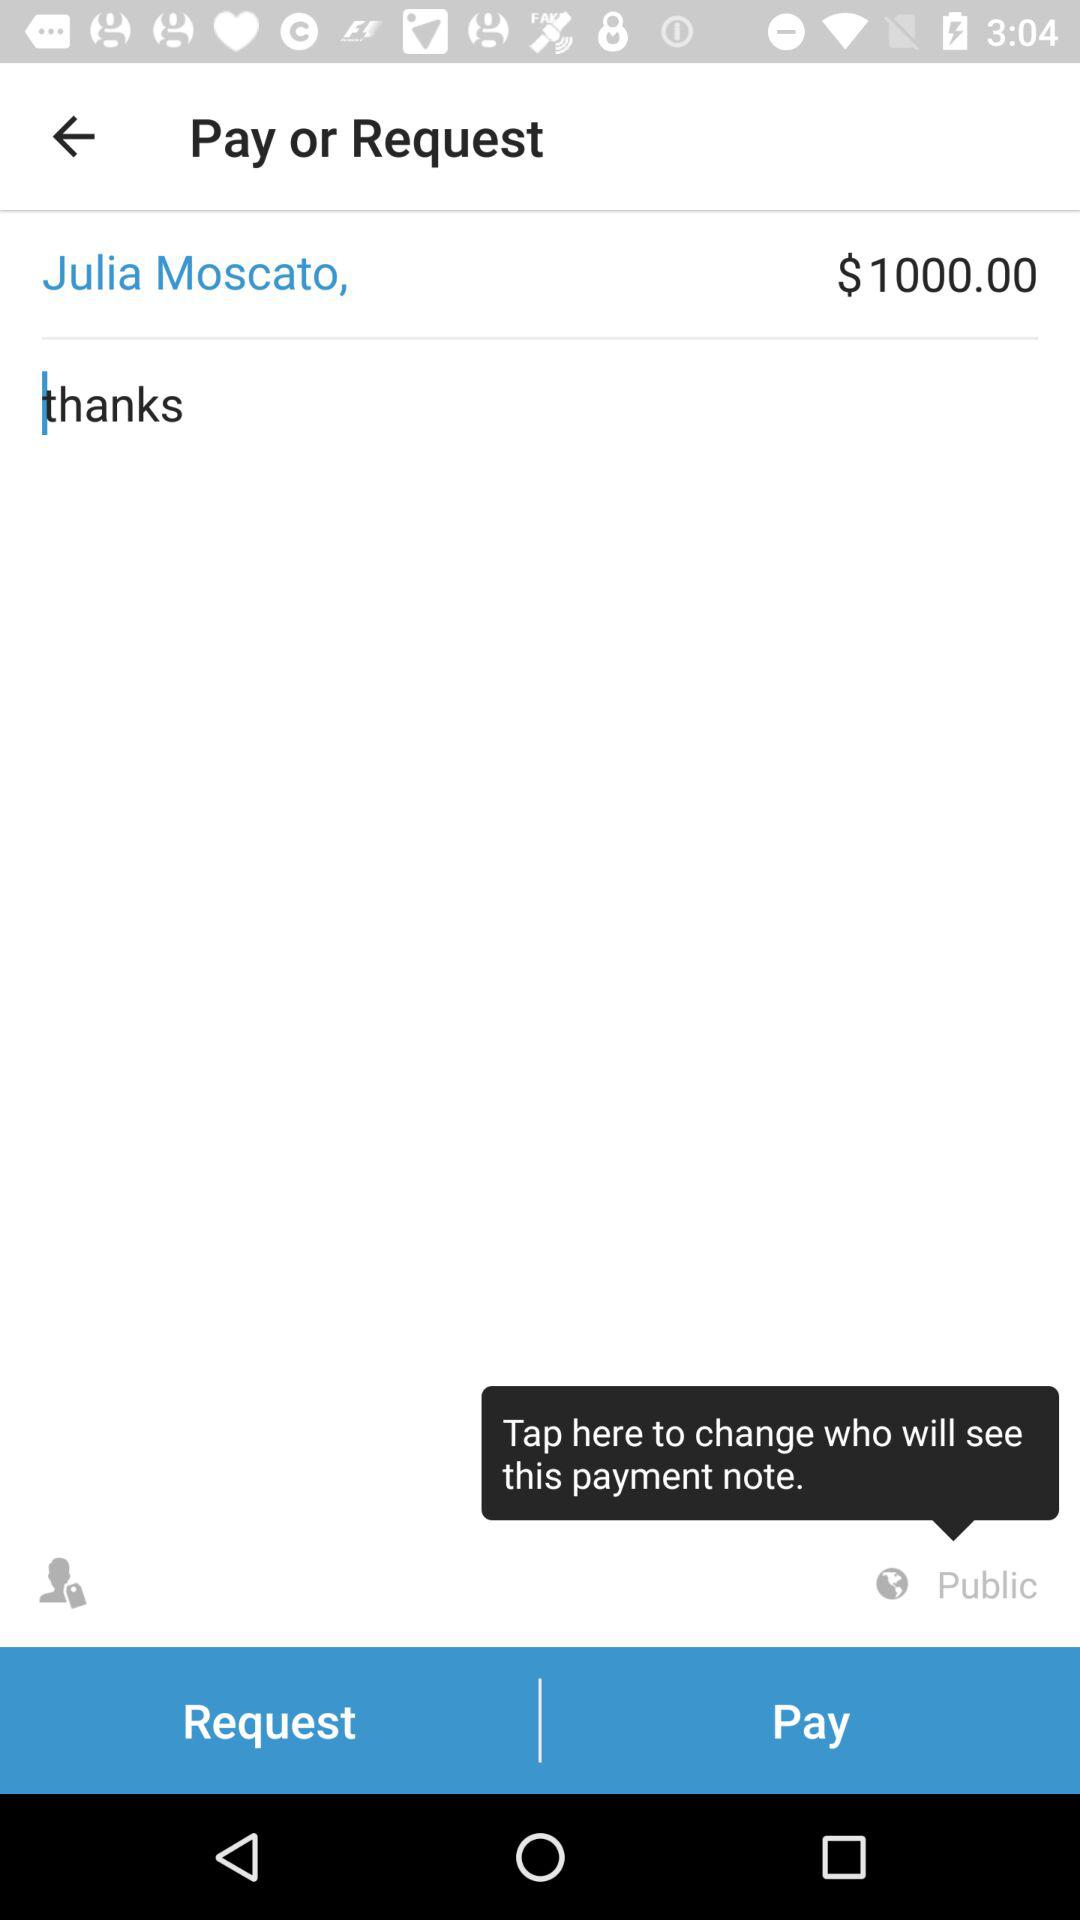How much is the amount of the payment?
Answer the question using a single word or phrase. $1000.00 